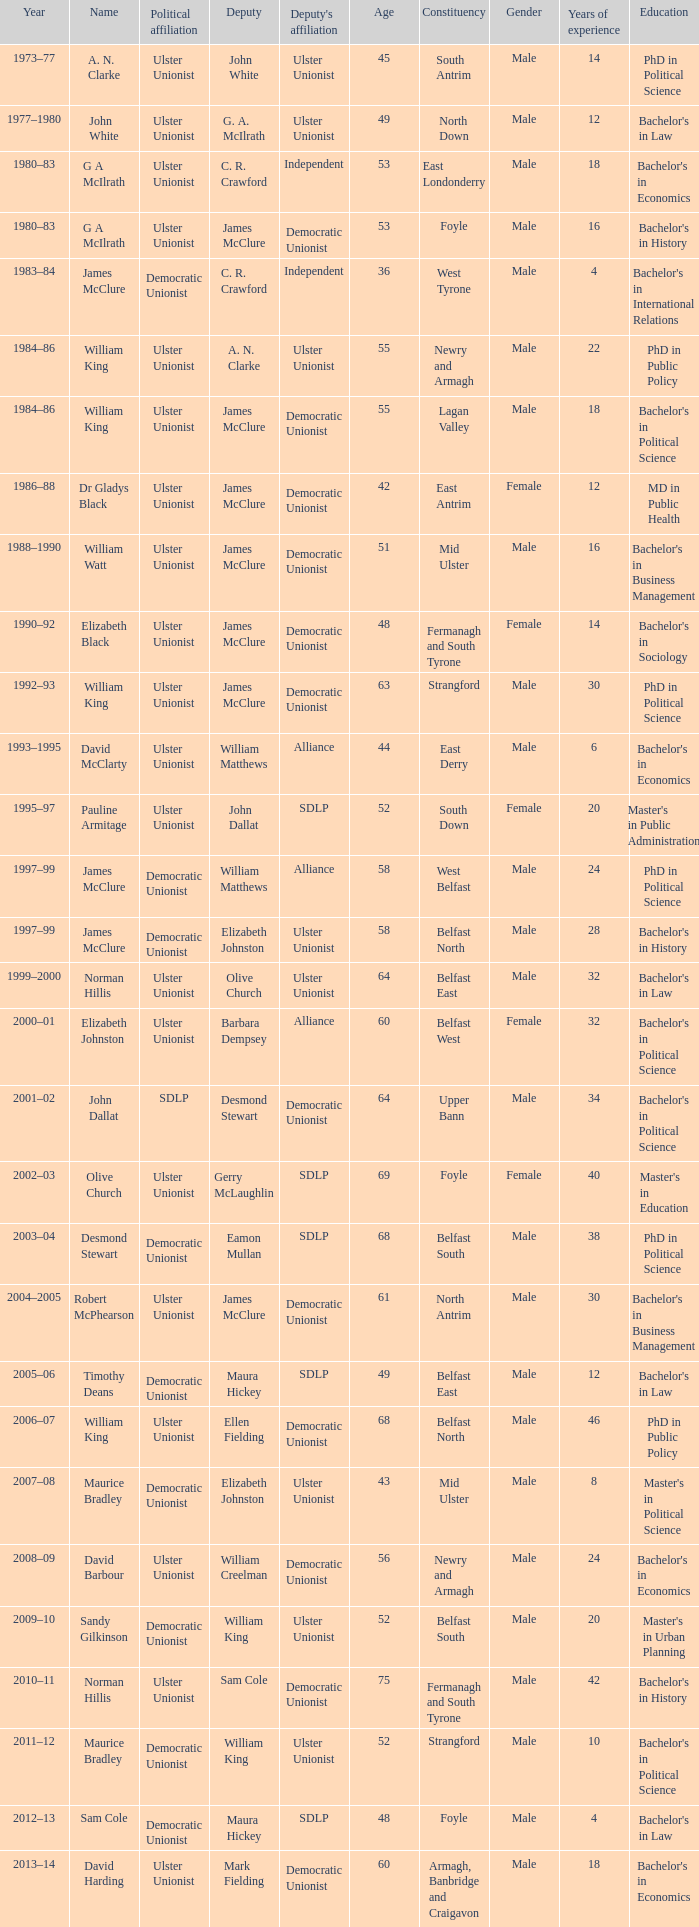What is the Deputy's affiliation in 1992–93? Democratic Unionist. 